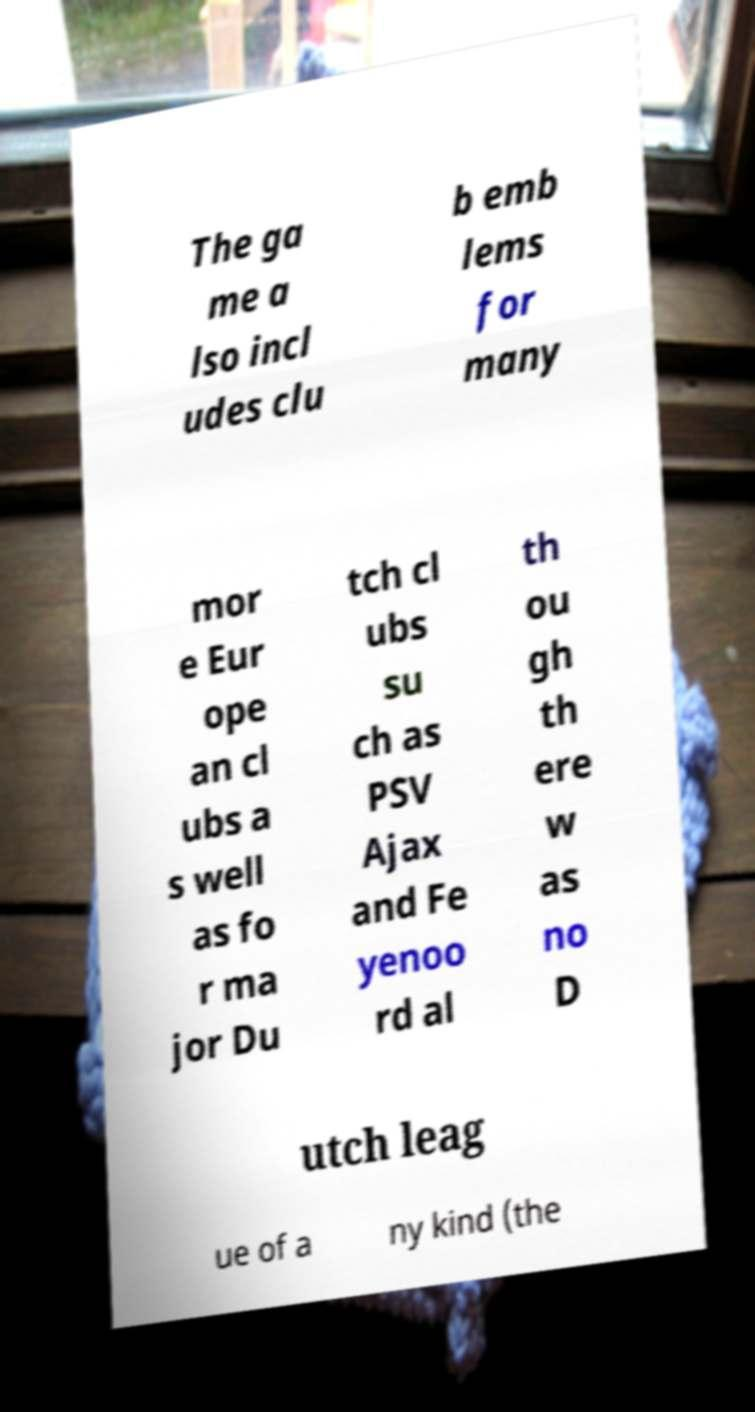Can you accurately transcribe the text from the provided image for me? The ga me a lso incl udes clu b emb lems for many mor e Eur ope an cl ubs a s well as fo r ma jor Du tch cl ubs su ch as PSV Ajax and Fe yenoo rd al th ou gh th ere w as no D utch leag ue of a ny kind (the 